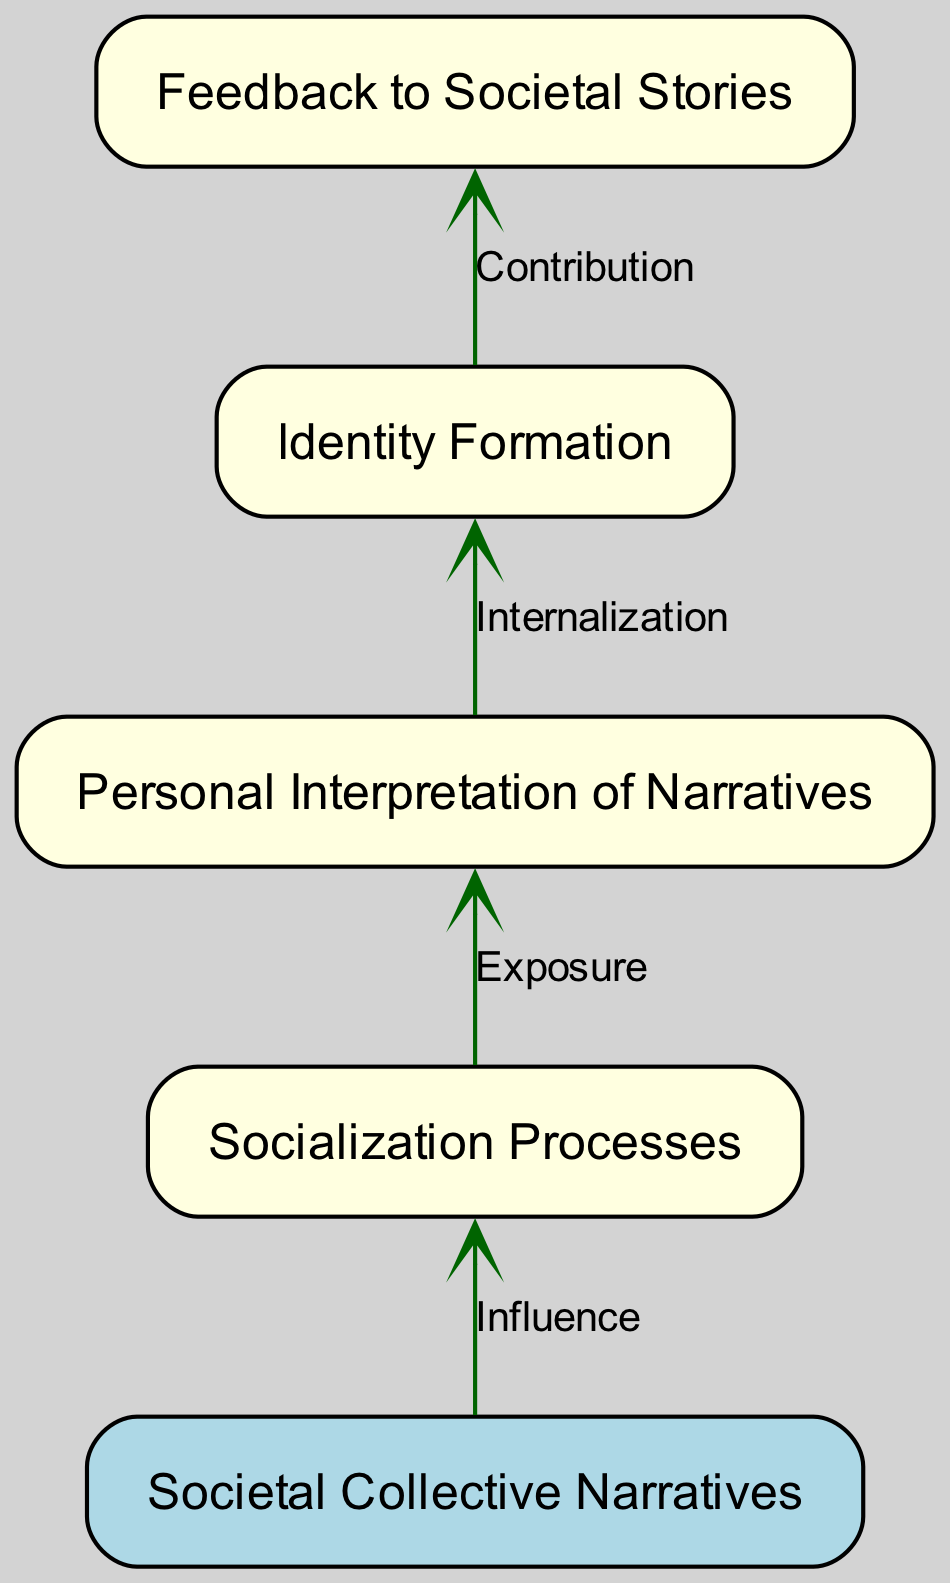What is the starting point of the flow in the diagram? The starting point of the flow is indicated as "Societal Collective Narratives." This is the first element placed at the bottom of the diagram, from which all other processes stem.
Answer: Societal Collective Narratives How many processes are depicted in the diagram? The diagram contains four processes, which are 'Socialization Processes,' 'Personal Interpretation of Narratives,' 'Identity Formation,' and 'Feedback to Societal Stories.' These processes flow upward, showcasing their interconnections.
Answer: Four What is the relationship between 'Socialization Processes' and 'Personal Interpretation of Narratives'? The relationship between these two nodes is that of "Exposure." This is indicated by an arrow from 'Socialization Processes' to 'Personal Interpretation of Narratives,' showing that socialization exposes individuals to narratives.
Answer: Exposure Which node provides feedback to societal collective narratives? The node that provides feedback to societal collective narratives is 'Feedback to Societal Stories.' It shows the process where individuals contribute back to collective narratives after internalizing their personal interpretations.
Answer: Feedback to Societal Stories What type of narrative influences the socialization process? The type of narrative that influences the socialization process is 'Societal Collective Narratives.' This is indicated as the input that drives the further processes in the flow chart.
Answer: Societal Collective Narratives What is the last process in the flow chart? The last process in the flow chart is 'Feedback to Societal Stories.' It represents the culmination of the individual's journey as they share and contribute back to societal narratives.
Answer: Feedback to Societal Stories How does 'Personal Interpretation of Narratives' affect 'Identity Formation'? 'Personal Interpretation of Narratives' affects 'Identity Formation' through the process described as "Internalization." This arrow signifies the impact of personal comprehension on the development of identity.
Answer: Internalization What addition occurs as a result of identity formation? The addition that occurs is the "Contribution" back to societal stories, as indicated by the arrow from 'Identity Formation' to 'Feedback to Societal Stories.' This represents the way individuals share their formed identities back into the collective narrative pool.
Answer: Contribution 